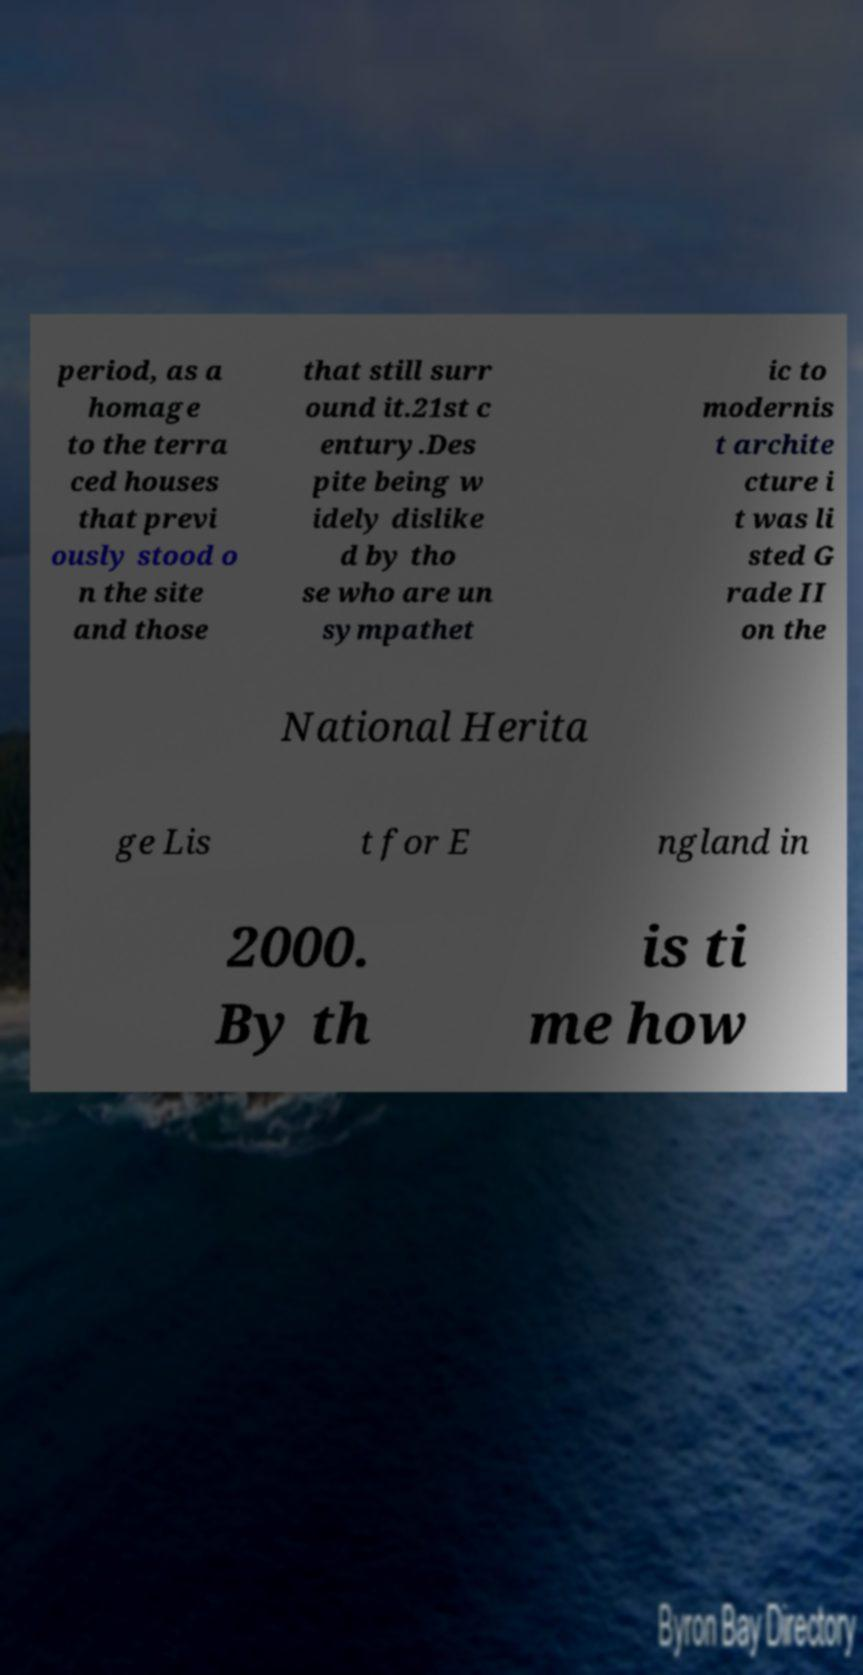Could you extract and type out the text from this image? period, as a homage to the terra ced houses that previ ously stood o n the site and those that still surr ound it.21st c entury.Des pite being w idely dislike d by tho se who are un sympathet ic to modernis t archite cture i t was li sted G rade II on the National Herita ge Lis t for E ngland in 2000. By th is ti me how 